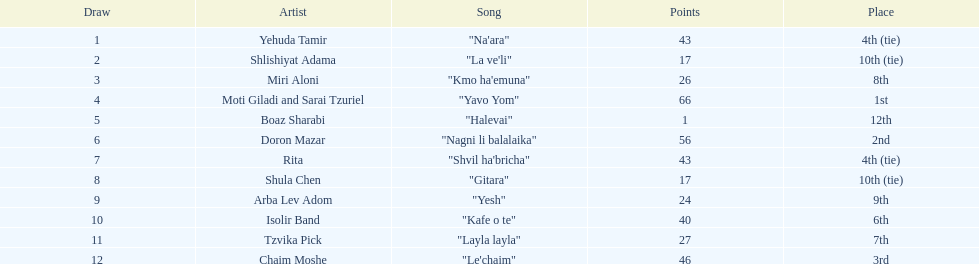What artist received the least amount of points in the competition? Boaz Sharabi. 